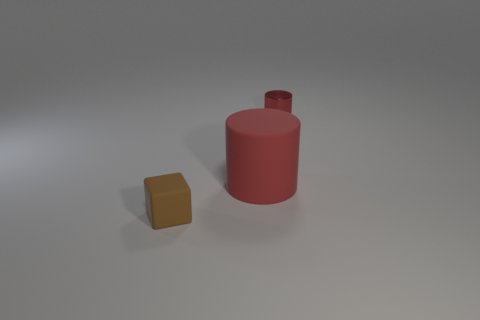Add 1 brown metallic things. How many objects exist? 4 Subtract all blocks. How many objects are left? 2 Add 1 brown matte objects. How many brown matte objects are left? 2 Add 1 large matte cylinders. How many large matte cylinders exist? 2 Subtract 0 cyan cylinders. How many objects are left? 3 Subtract all brown things. Subtract all tiny brown things. How many objects are left? 1 